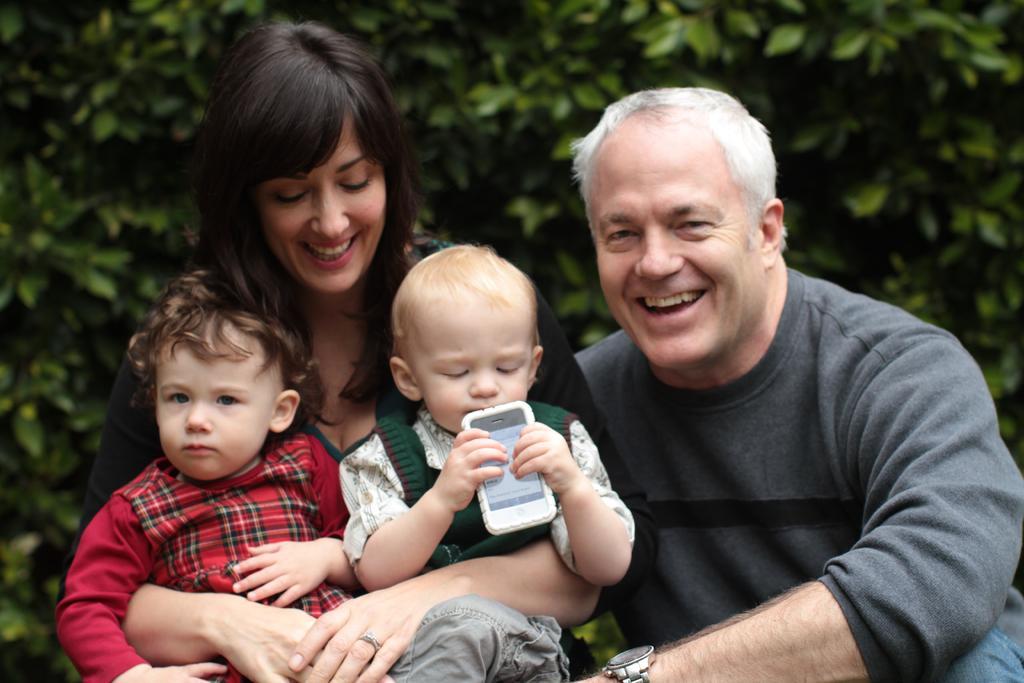Could you give a brief overview of what you see in this image? In this picture I can observe a man and a woman. Both of them are smiling. There are two kids in the hands of a woman. In the background I can observe trees. 